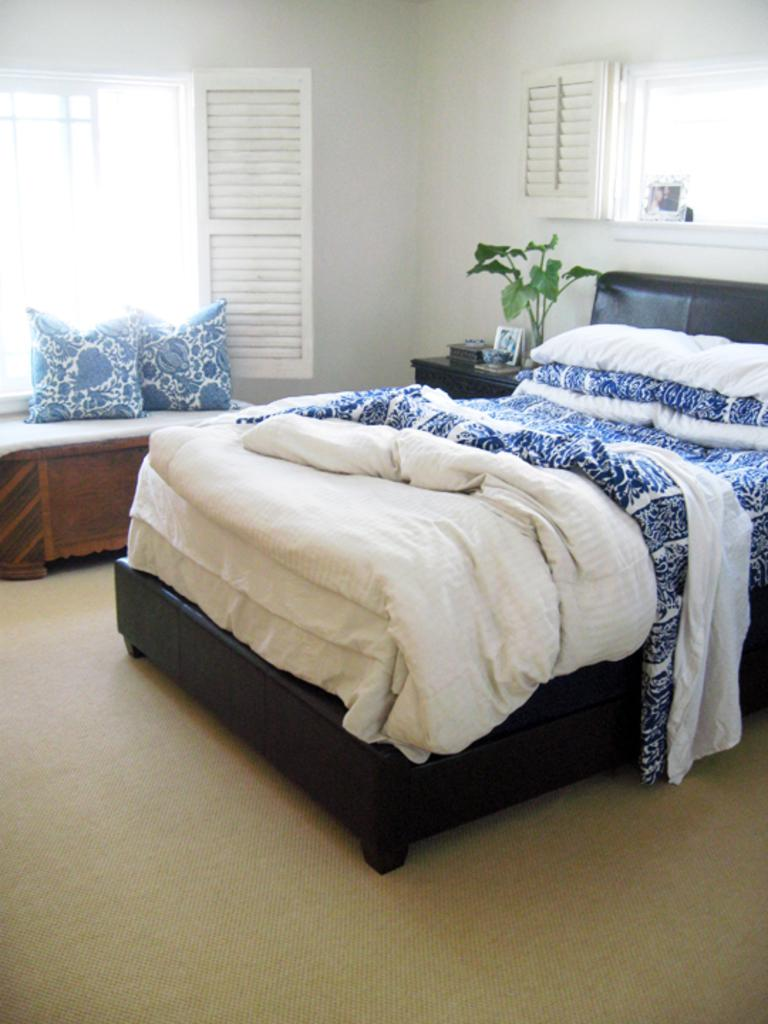What type of furniture is present in the room? There is a bed in the room. Are there any decorative or living elements in the room? Yes, there is a house plant in the room. What can be seen through the window in the room? The presence of a window suggests that there is a view outside the room. What is one of the structural elements in the room? There is a wall in the room. What can be found on the left side of the bed? There are pillows on the left side of the bed. What type of thunder can be heard coming from the self in the image? There is no thunder or self present in the image; it features a room with a bed, house plant, window, wall, and pillows. 